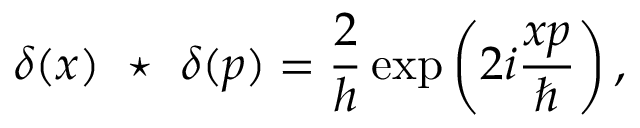<formula> <loc_0><loc_0><loc_500><loc_500>\delta ( x ) ^ { * } \delta ( p ) = { \frac { 2 } { h } } \exp \left ( 2 i { \frac { x p } { } } \right ) ,</formula> 